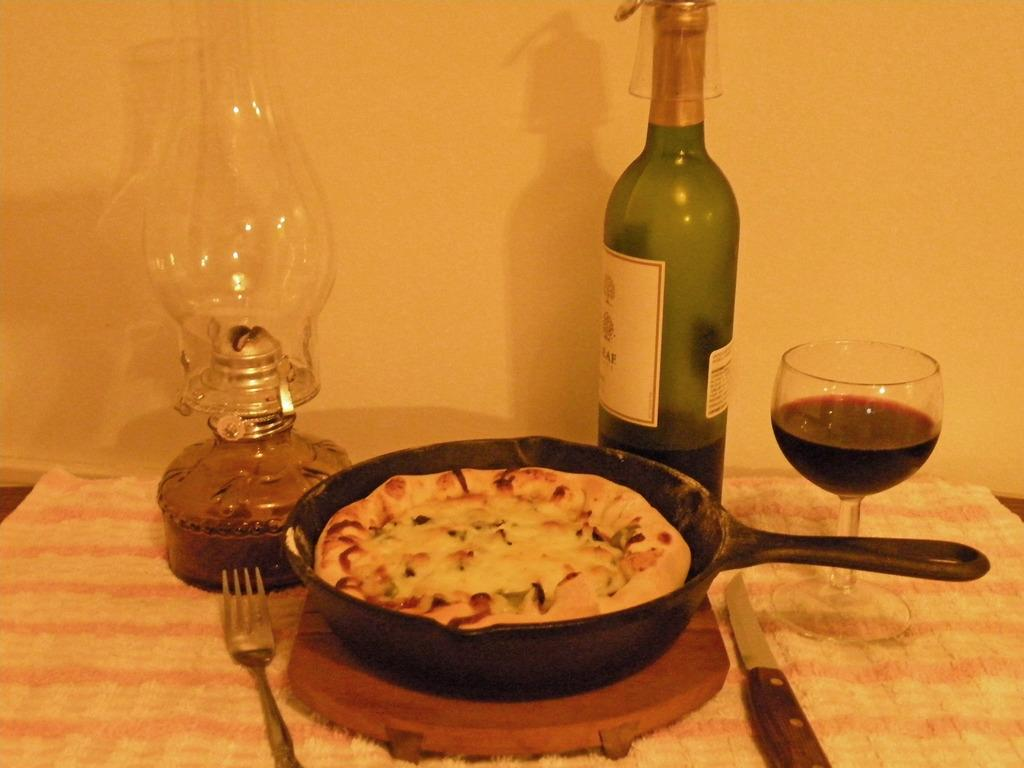What type of structure can be seen in the image? There is a wall in the image. What type of furniture is present in the image? There is a table in the image. What is covering the table? There is a tablecloth on the table. What type of cooking equipment is visible in the image? There is a pan in the image. What type of food can be seen in the image? There is food in the image. What type of utensil is present in the image? There is a fork in the image. What type of cutting tool is present in the image? There is a knife in the image. What type of beverage container is present in the image? There is a bottle in the image. What type of drink is present in the image? There is a glass of wine in the image. How many leaves are on the table in the image? There are no leaves present on the table in the image. What type of snow can be seen falling in the image? There is no snow present in the image. What color is the eye of the person in the image? There is no person present in the image, so it is not possible to determine the color of their eye. 